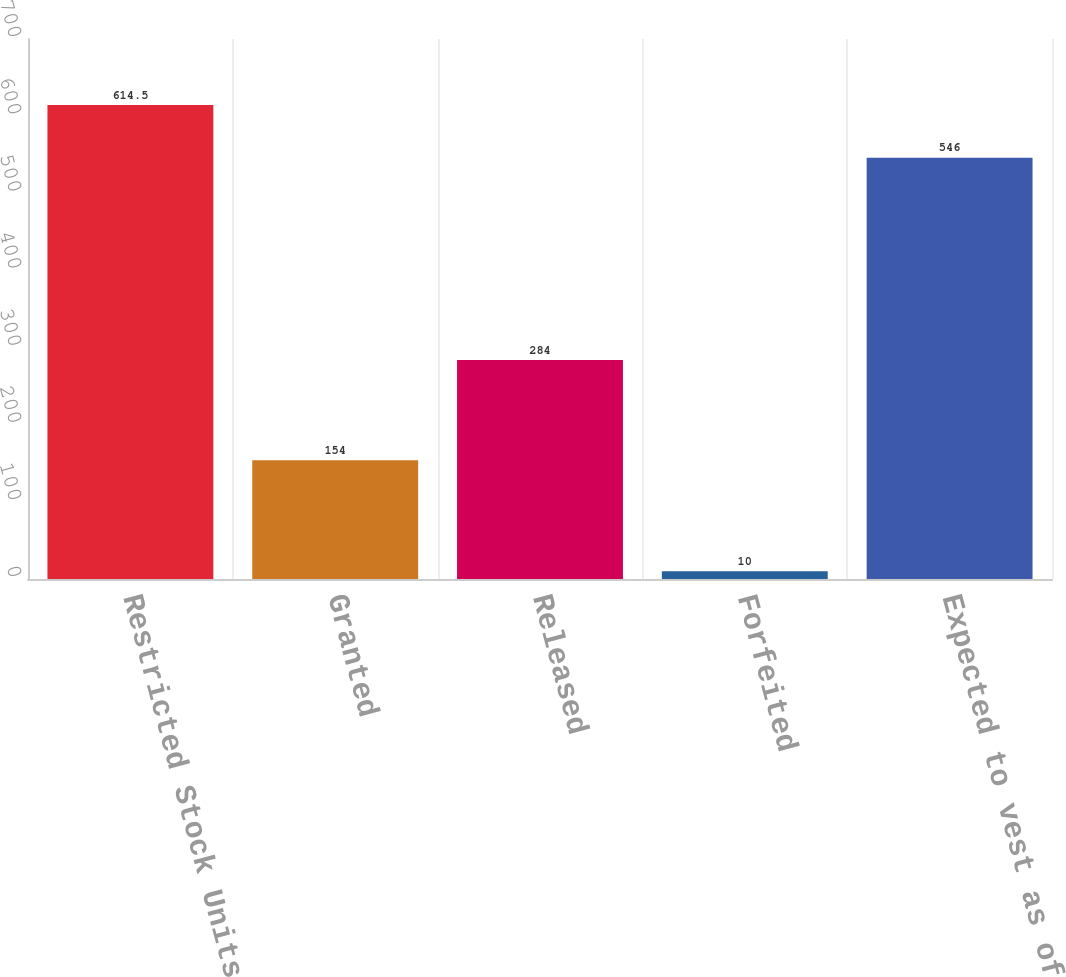Convert chart. <chart><loc_0><loc_0><loc_500><loc_500><bar_chart><fcel>Restricted Stock Units<fcel>Granted<fcel>Released<fcel>Forfeited<fcel>Expected to vest as of<nl><fcel>614.5<fcel>154<fcel>284<fcel>10<fcel>546<nl></chart> 